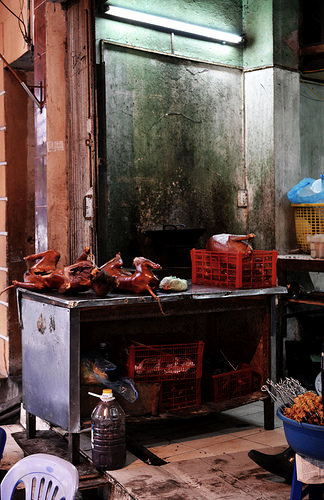<image>
Can you confirm if the meat is in the plastic basin? Yes. The meat is contained within or inside the plastic basin, showing a containment relationship. 